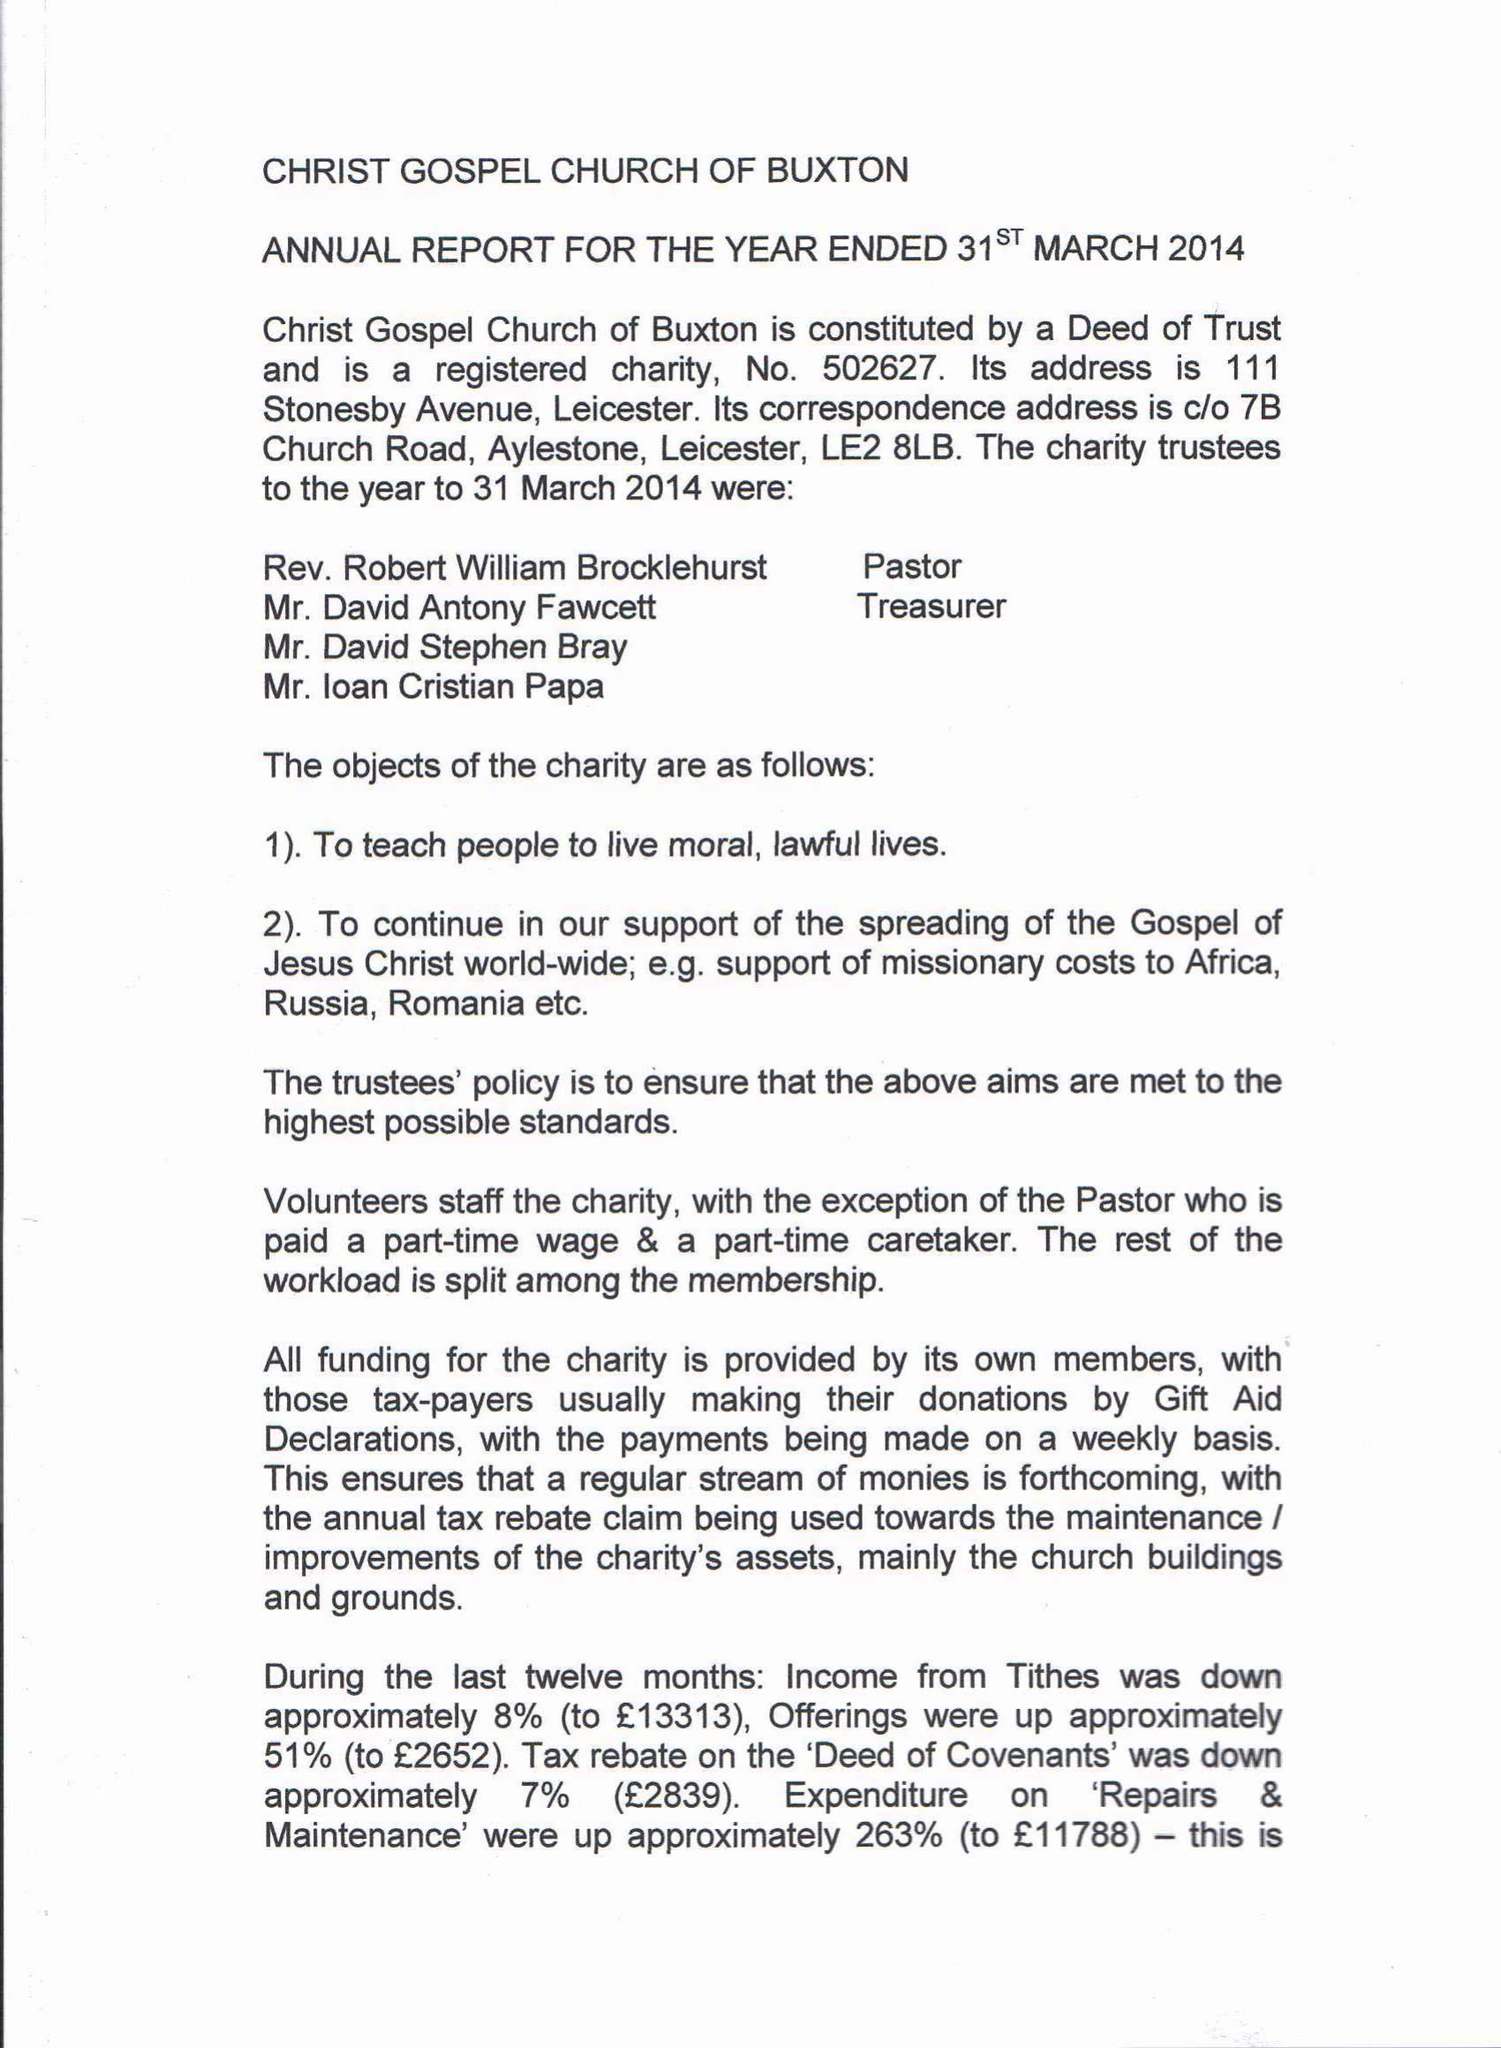What is the value for the address__street_line?
Answer the question using a single word or phrase. 7B CHURCH ROAD 